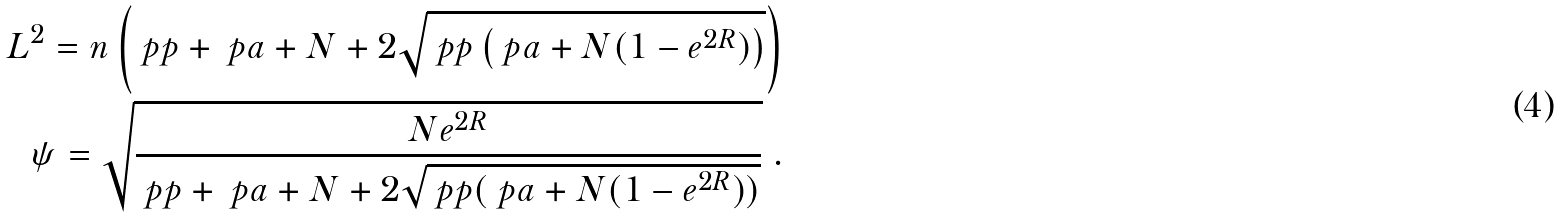Convert formula to latex. <formula><loc_0><loc_0><loc_500><loc_500>L ^ { 2 } = { n \left ( \ p p + \ p a + N + 2 \sqrt { \ p p \left ( \ p a + N ( 1 - e ^ { 2 R } ) \right ) } \right ) } \\ \psi = \sqrt { \frac { N e ^ { 2 R } } { \ p p + \ p a + N + 2 \sqrt { \ p p ( \ p a + N ( 1 - e ^ { 2 R } ) ) } } } \ .</formula> 